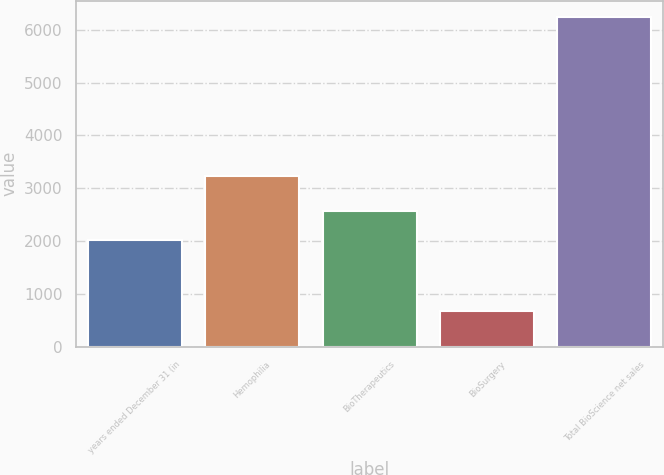Convert chart to OTSL. <chart><loc_0><loc_0><loc_500><loc_500><bar_chart><fcel>years ended December 31 (in<fcel>Hemophilia<fcel>BioTherapeutics<fcel>BioSurgery<fcel>Total BioScience net sales<nl><fcel>2012<fcel>3241<fcel>2568.4<fcel>673<fcel>6237<nl></chart> 